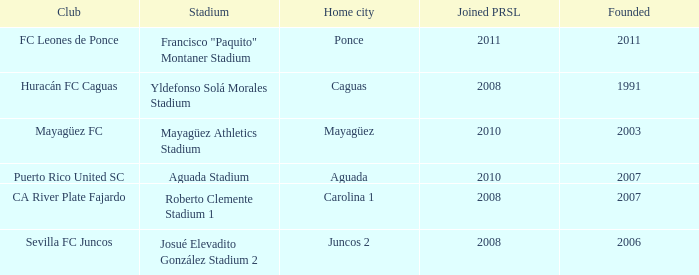When is the club founded that founed prsl in 2008 and the home city is carolina 1? 2007.0. 